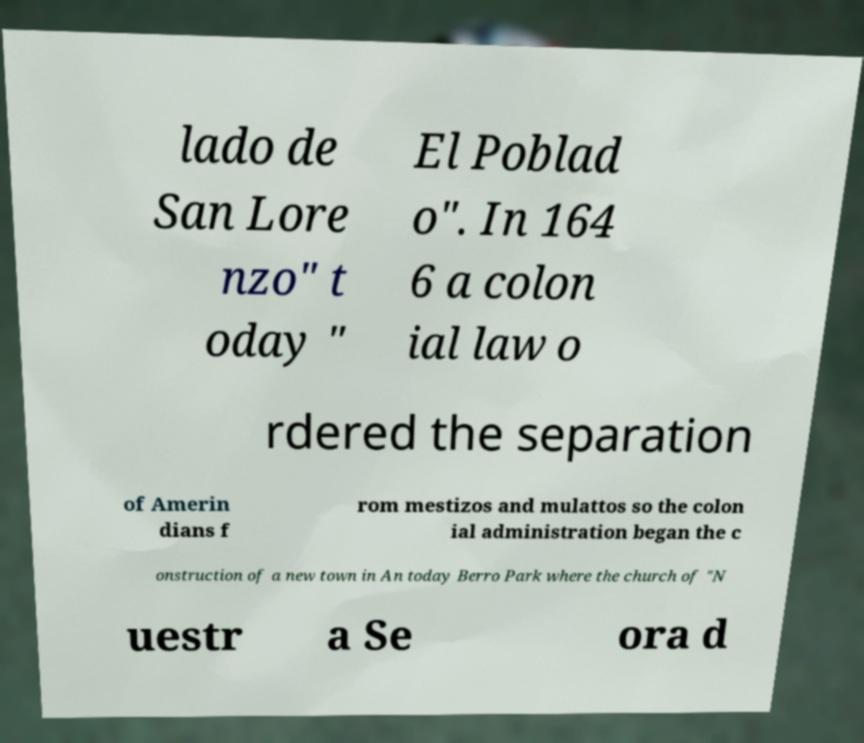Could you extract and type out the text from this image? lado de San Lore nzo" t oday " El Poblad o". In 164 6 a colon ial law o rdered the separation of Amerin dians f rom mestizos and mulattos so the colon ial administration began the c onstruction of a new town in An today Berro Park where the church of "N uestr a Se ora d 